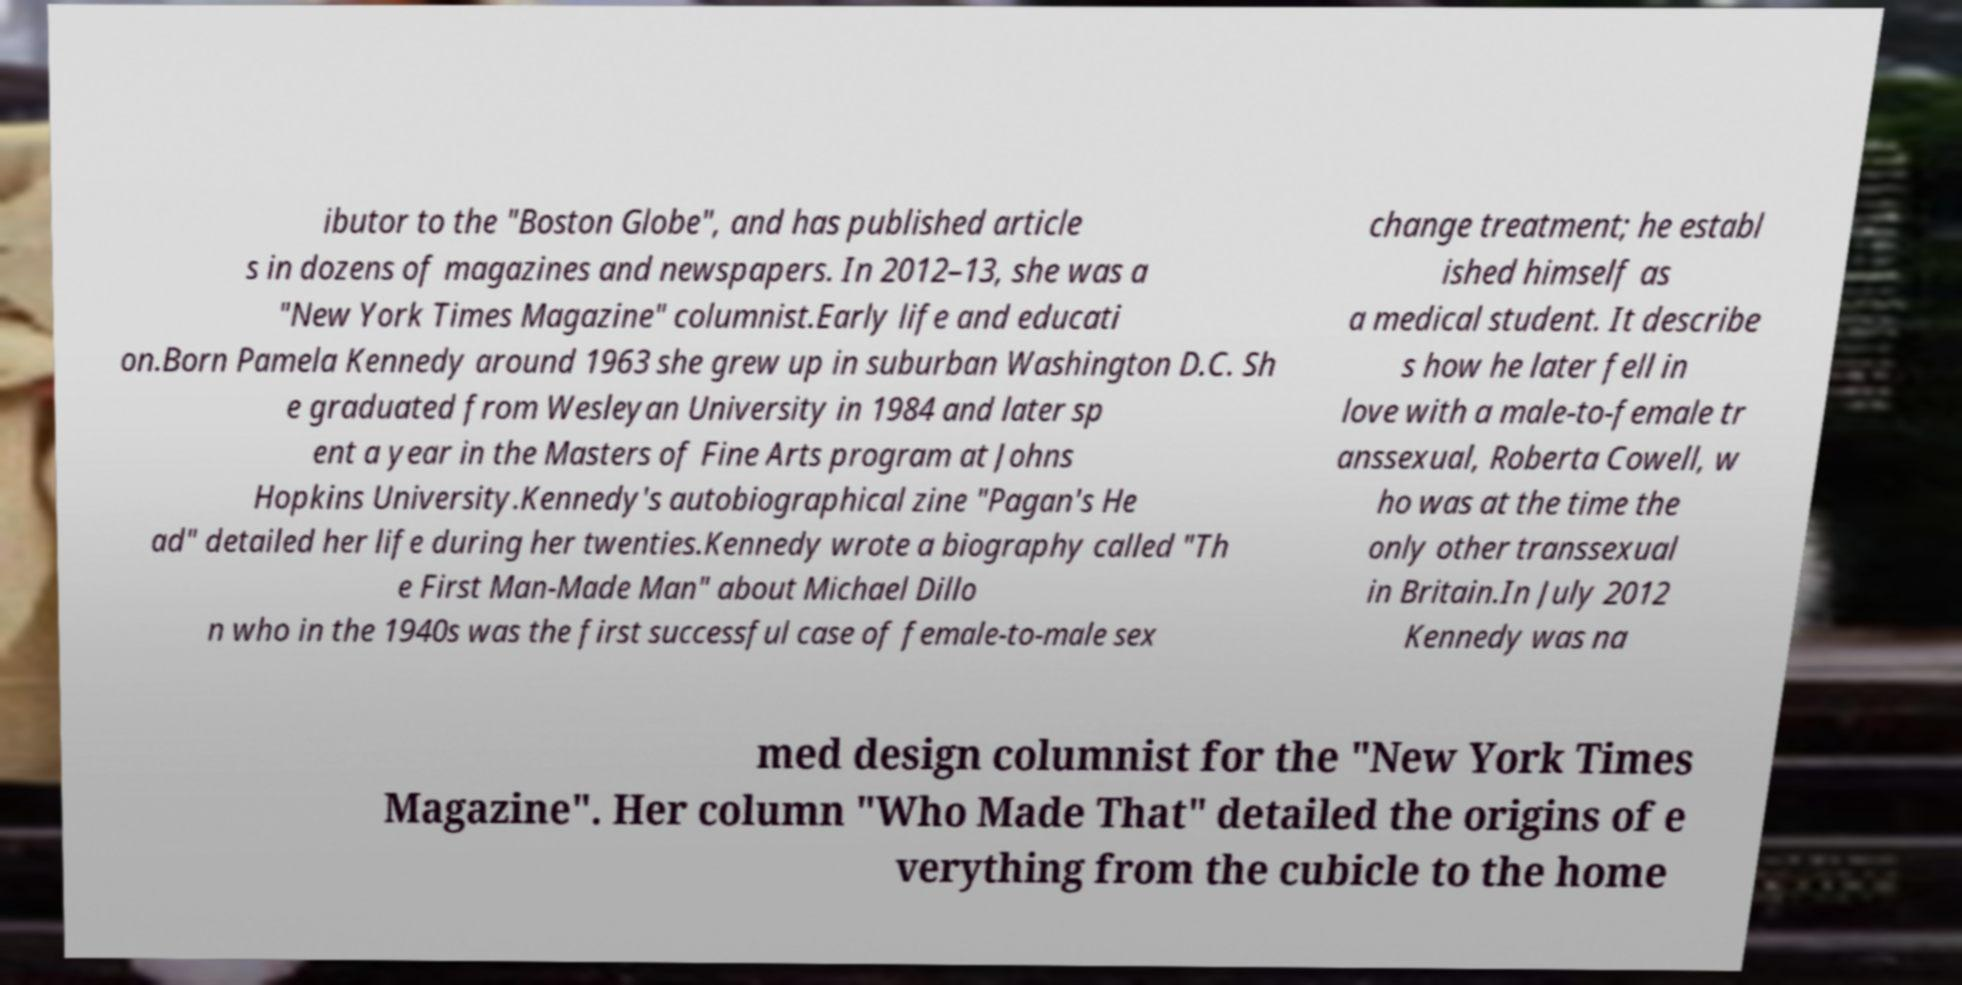Please identify and transcribe the text found in this image. ibutor to the "Boston Globe", and has published article s in dozens of magazines and newspapers. In 2012–13, she was a "New York Times Magazine" columnist.Early life and educati on.Born Pamela Kennedy around 1963 she grew up in suburban Washington D.C. Sh e graduated from Wesleyan University in 1984 and later sp ent a year in the Masters of Fine Arts program at Johns Hopkins University.Kennedy's autobiographical zine "Pagan's He ad" detailed her life during her twenties.Kennedy wrote a biography called "Th e First Man-Made Man" about Michael Dillo n who in the 1940s was the first successful case of female-to-male sex change treatment; he establ ished himself as a medical student. It describe s how he later fell in love with a male-to-female tr anssexual, Roberta Cowell, w ho was at the time the only other transsexual in Britain.In July 2012 Kennedy was na med design columnist for the "New York Times Magazine". Her column "Who Made That" detailed the origins of e verything from the cubicle to the home 